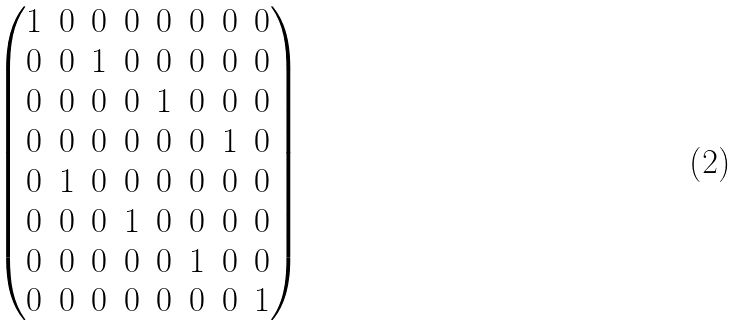Convert formula to latex. <formula><loc_0><loc_0><loc_500><loc_500>\begin{pmatrix} 1 & 0 & 0 & 0 & 0 & 0 & 0 & 0 \\ 0 & 0 & 1 & 0 & 0 & 0 & 0 & 0 \\ 0 & 0 & 0 & 0 & 1 & 0 & 0 & 0 \\ 0 & 0 & 0 & 0 & 0 & 0 & 1 & 0 \\ 0 & 1 & 0 & 0 & 0 & 0 & 0 & 0 \\ 0 & 0 & 0 & 1 & 0 & 0 & 0 & 0 \\ 0 & 0 & 0 & 0 & 0 & 1 & 0 & 0 \\ 0 & 0 & 0 & 0 & 0 & 0 & 0 & 1 \end{pmatrix}</formula> 